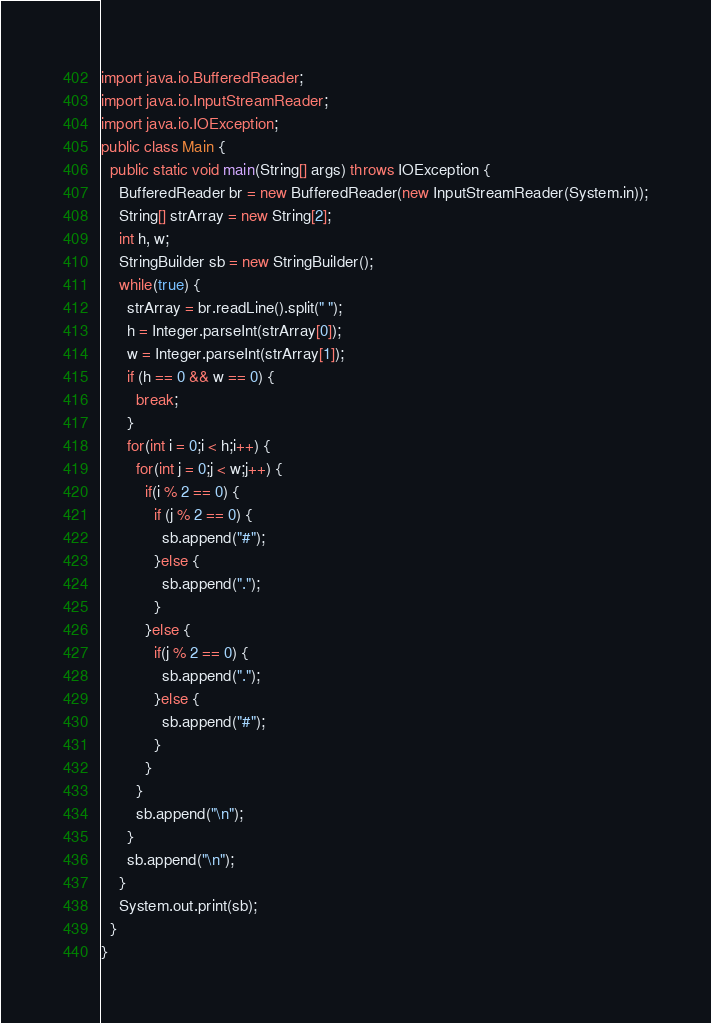<code> <loc_0><loc_0><loc_500><loc_500><_Java_>import java.io.BufferedReader;
import java.io.InputStreamReader;
import java.io.IOException;
public class Main {
  public static void main(String[] args) throws IOException {
    BufferedReader br = new BufferedReader(new InputStreamReader(System.in));
    String[] strArray = new String[2];
    int h, w;
    StringBuilder sb = new StringBuilder();
    while(true) {
      strArray = br.readLine().split(" ");
      h = Integer.parseInt(strArray[0]);
      w = Integer.parseInt(strArray[1]);
      if (h == 0 && w == 0) {
        break;
      }
      for(int i = 0;i < h;i++) {
        for(int j = 0;j < w;j++) {
          if(i % 2 == 0) {
            if (j % 2 == 0) {
              sb.append("#");
            }else {
              sb.append(".");
            }
          }else {
            if(j % 2 == 0) {
              sb.append(".");
            }else {
              sb.append("#");
            }
          }
        }
        sb.append("\n");
      }
      sb.append("\n");
    }
    System.out.print(sb);
  }
}</code> 